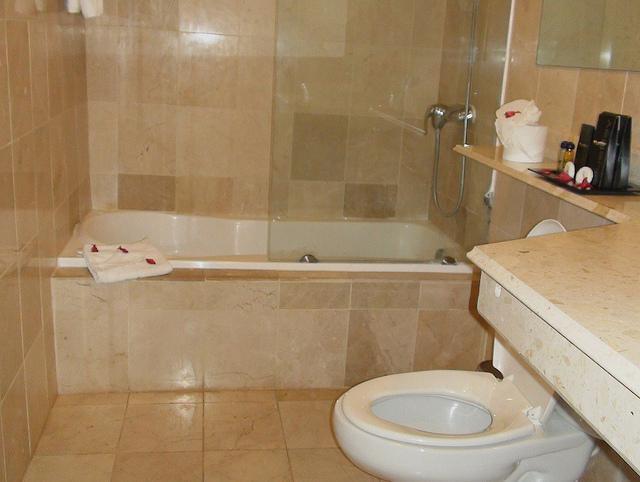How many people are visible?
Give a very brief answer. 0. 